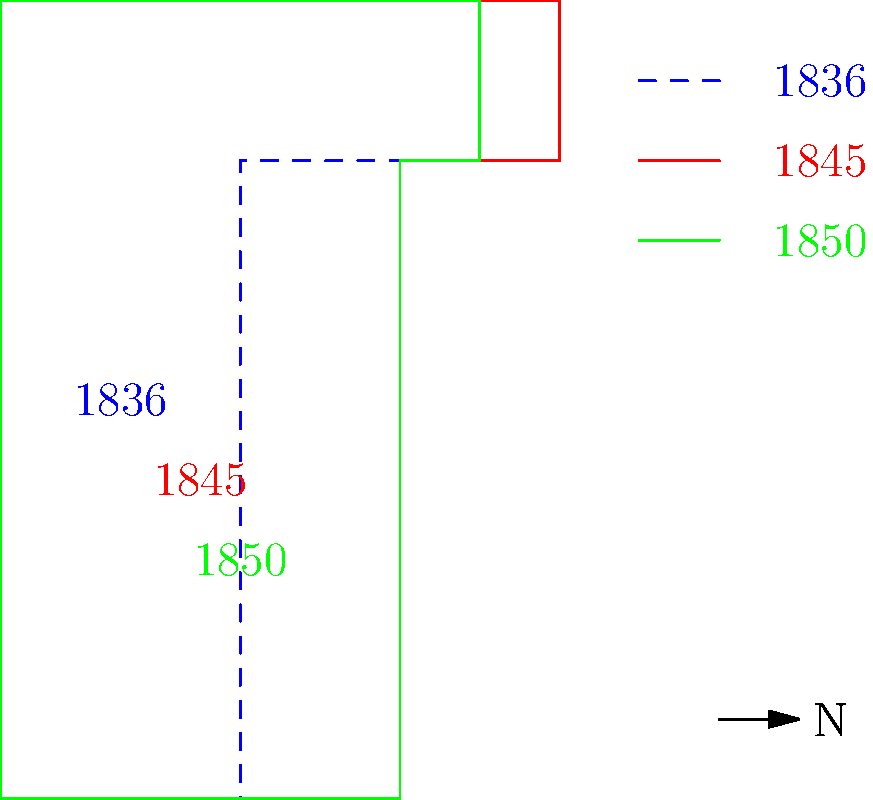Based on the map showing the changing borders of Texas, which year marked the most significant expansion of Texas territory, and what historical event likely caused this change? To answer this question, let's analyze the map step-by-step:

1. The map shows three different borders of Texas, represented by different colors and years:
   - Blue dashed line: 1836
   - Red solid line: 1845
   - Green solid line: 1850

2. Comparing the three borders:
   - The 1836 border (blue dashed line) shows the smallest area.
   - The 1845 border (red solid line) shows a significant expansion to the west.
   - The 1850 border (green solid line) shows a slight reduction from the 1845 border.

3. The most significant expansion occurred between 1836 and 1845, as evidenced by the large increase in territory to the west.

4. Historically, this expansion coincides with a major event in Texas history: the annexation of Texas by the United States in 1845.

5. Before 1845, Texas was an independent republic (Republic of Texas, 1836-1845). The annexation by the United States allowed Texas to claim a larger territory, including areas that were disputed with Mexico.

6. The slight reduction in territory from 1845 to 1850 is likely due to the Compromise of 1850, which established the current borders of Texas.

Therefore, the year that marked the most significant expansion of Texas territory was 1845, and this change was likely caused by the annexation of Texas by the United States.
Answer: 1845; Texas annexation by the United States 